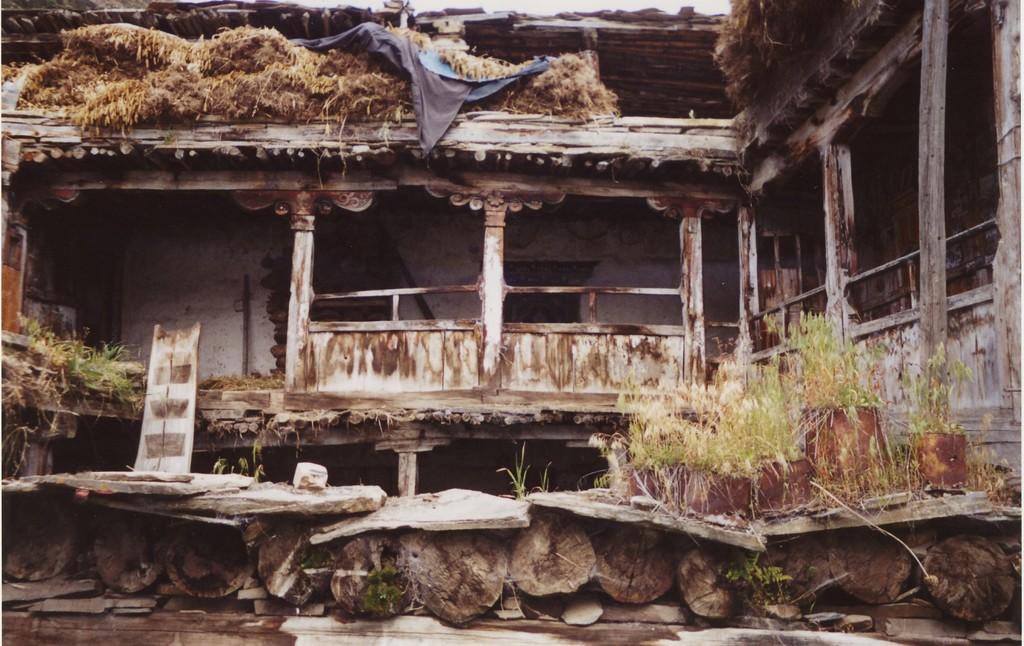Could you give a brief overview of what you see in this image? In this image we can see a wooden building, logs, walls and grass. 